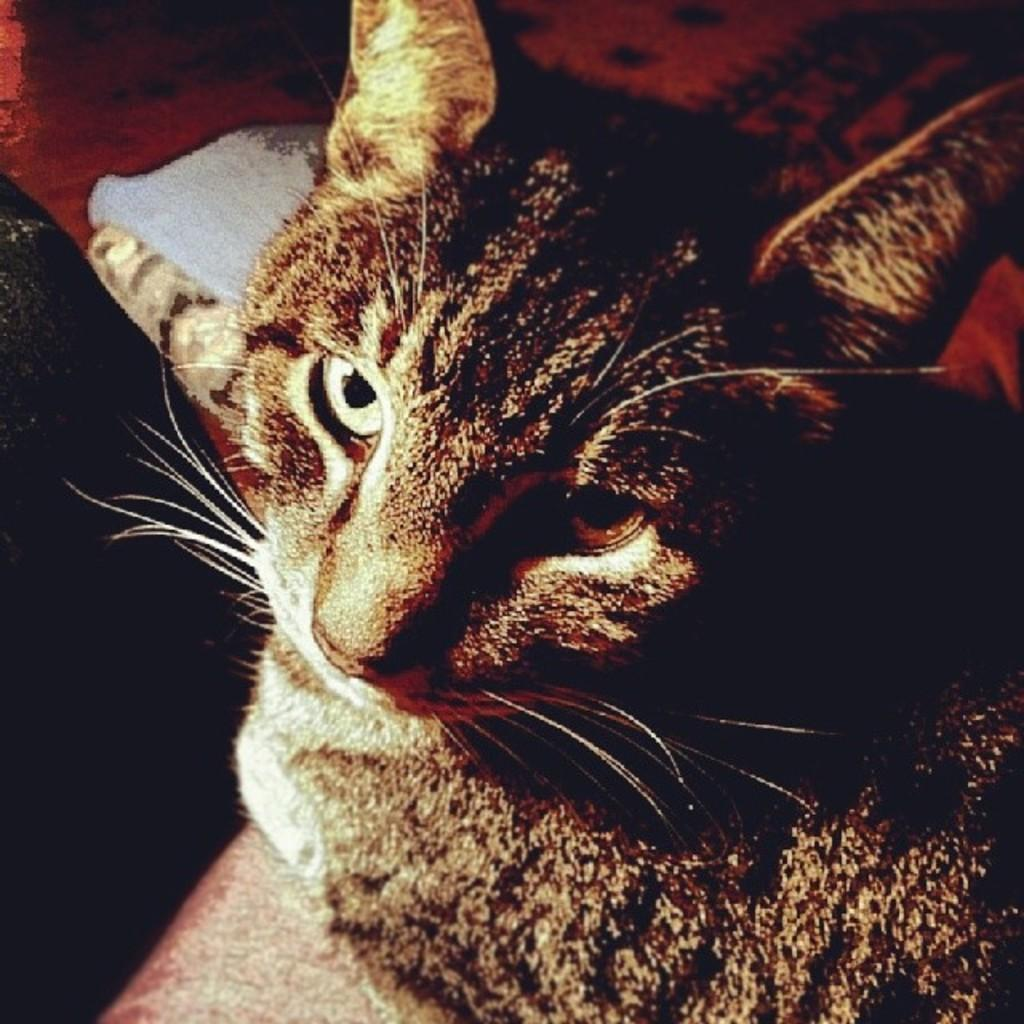What type of animal is in the image? There is a cat in the image. What is the cat doing in the image? The cat is looking at the camera. Where might the cat be sitting in the image? The cat might be sitting on a sofa chair. What color is the object that the cat might be sitting on? There is a red color thing in the image, which might be a sofa. What type of authority does the cat have in the image? The image does not depict any authority figures or situations, so the cat does not have any authority in the image. 